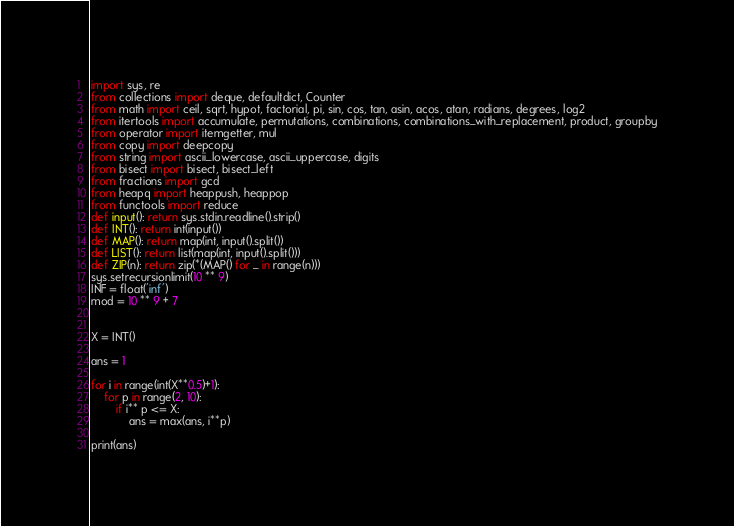<code> <loc_0><loc_0><loc_500><loc_500><_Python_>import sys, re
from collections import deque, defaultdict, Counter
from math import ceil, sqrt, hypot, factorial, pi, sin, cos, tan, asin, acos, atan, radians, degrees, log2
from itertools import accumulate, permutations, combinations, combinations_with_replacement, product, groupby
from operator import itemgetter, mul
from copy import deepcopy
from string import ascii_lowercase, ascii_uppercase, digits
from bisect import bisect, bisect_left
from fractions import gcd
from heapq import heappush, heappop
from functools import reduce
def input(): return sys.stdin.readline().strip()
def INT(): return int(input())
def MAP(): return map(int, input().split())
def LIST(): return list(map(int, input().split()))
def ZIP(n): return zip(*(MAP() for _ in range(n)))
sys.setrecursionlimit(10 ** 9)
INF = float('inf')
mod = 10 ** 9 + 7


X = INT()

ans = 1

for i in range(int(X**0.5)+1):
	for p in range(2, 10):
		if i** p <= X:
			ans = max(ans, i**p)

print(ans)</code> 